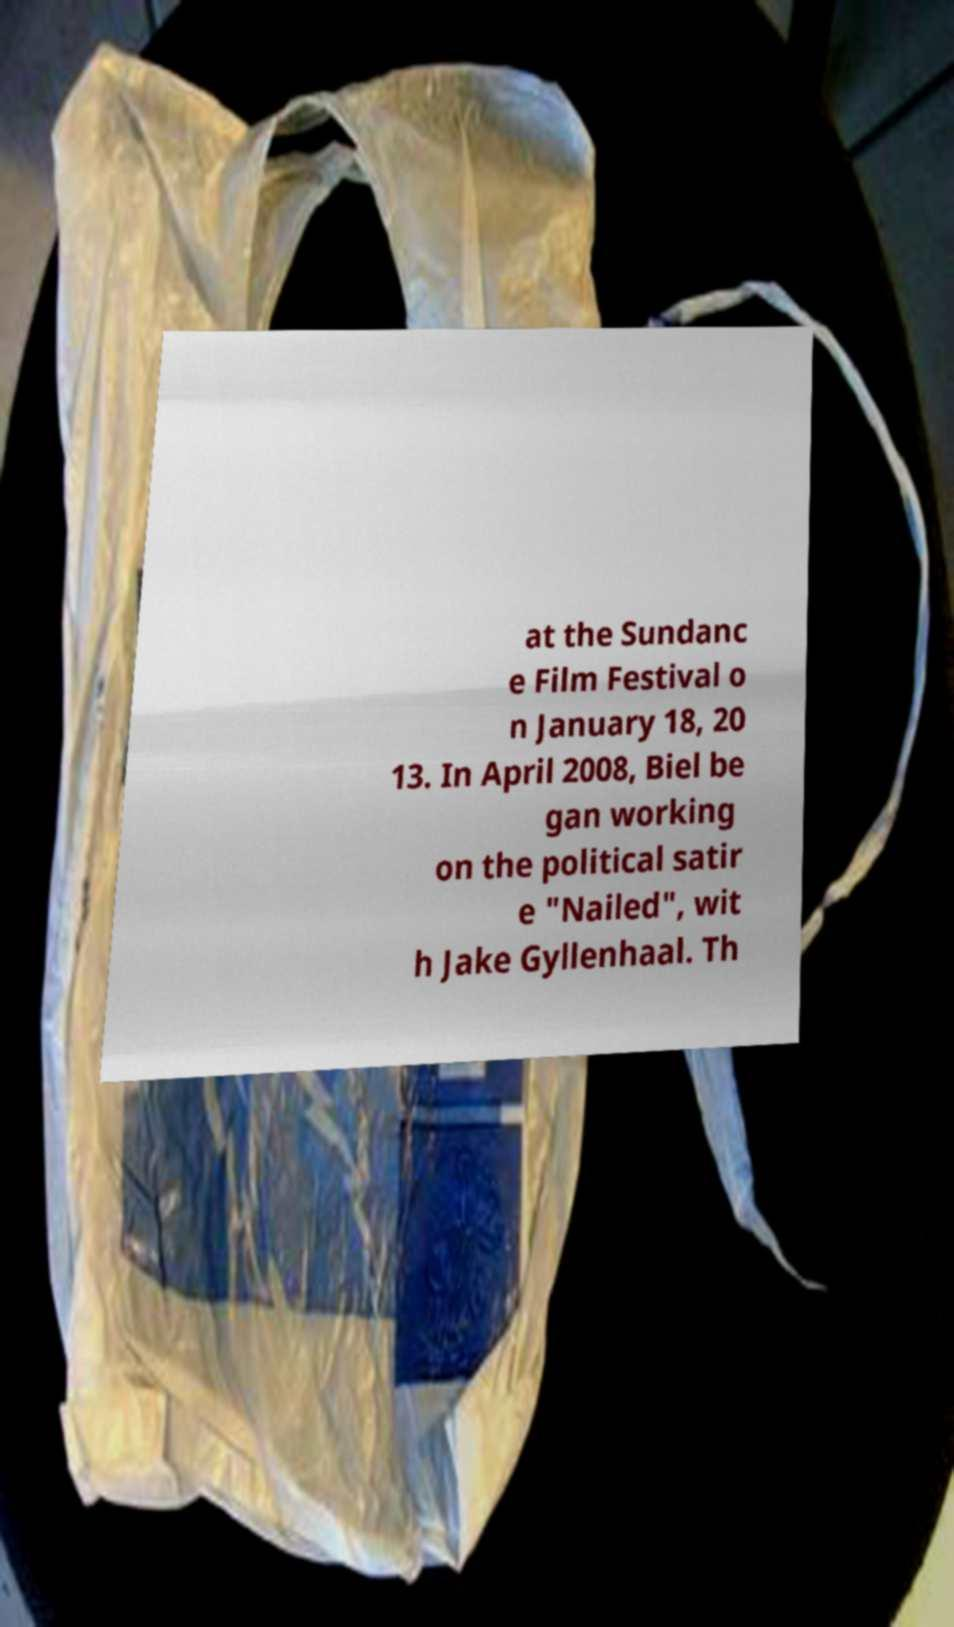Can you accurately transcribe the text from the provided image for me? at the Sundanc e Film Festival o n January 18, 20 13. In April 2008, Biel be gan working on the political satir e "Nailed", wit h Jake Gyllenhaal. Th 